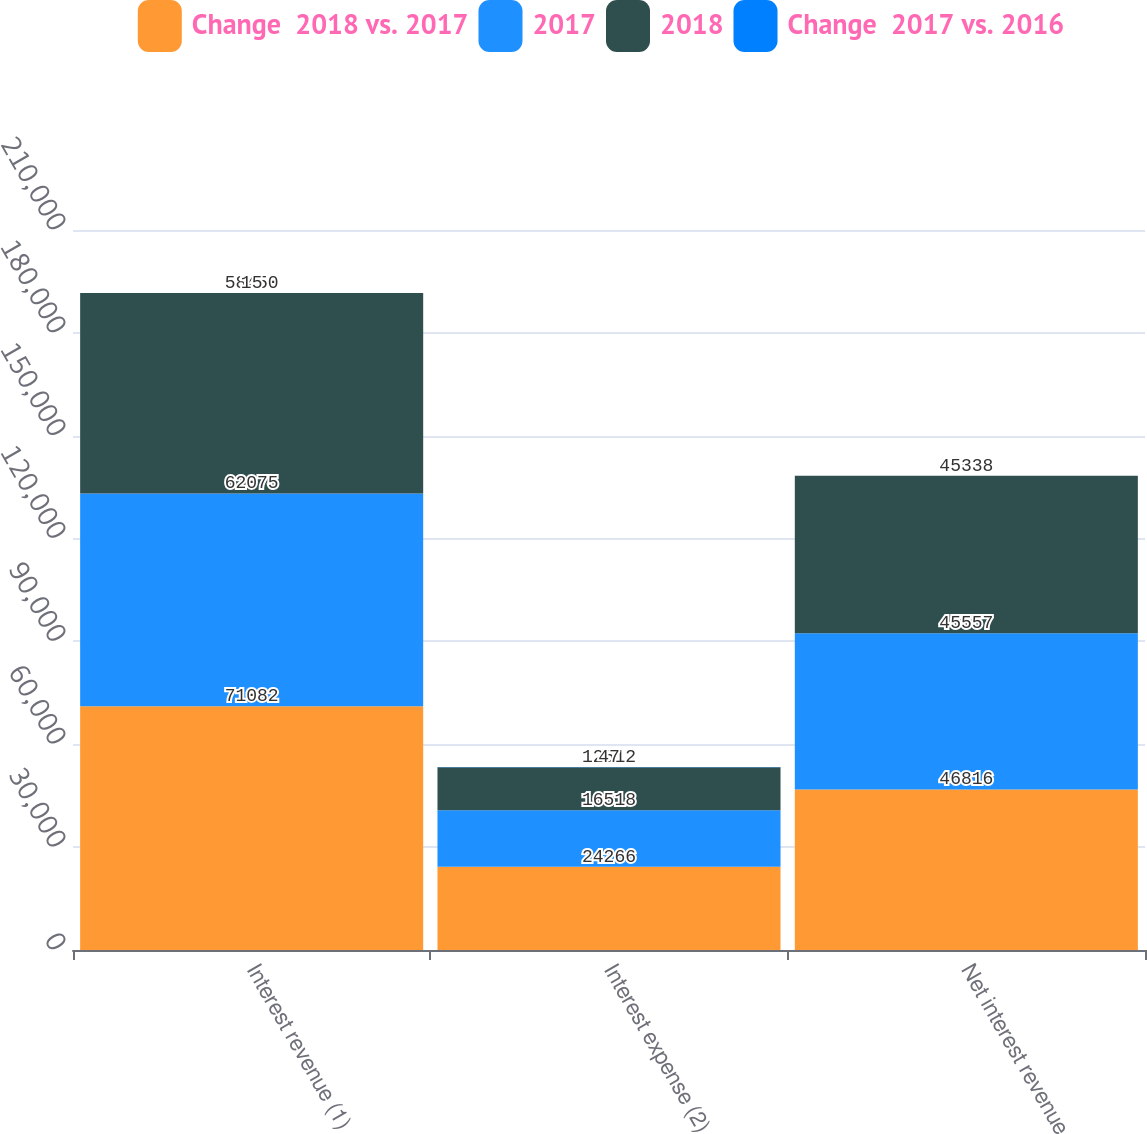Convert chart to OTSL. <chart><loc_0><loc_0><loc_500><loc_500><stacked_bar_chart><ecel><fcel>Interest revenue (1)<fcel>Interest expense (2)<fcel>Net interest revenue<nl><fcel>Change  2018 vs. 2017<fcel>71082<fcel>24266<fcel>46816<nl><fcel>2017<fcel>62075<fcel>16518<fcel>45557<nl><fcel>2018<fcel>58450<fcel>12512<fcel>45938<nl><fcel>Change  2017 vs. 2016<fcel>15<fcel>47<fcel>3<nl></chart> 